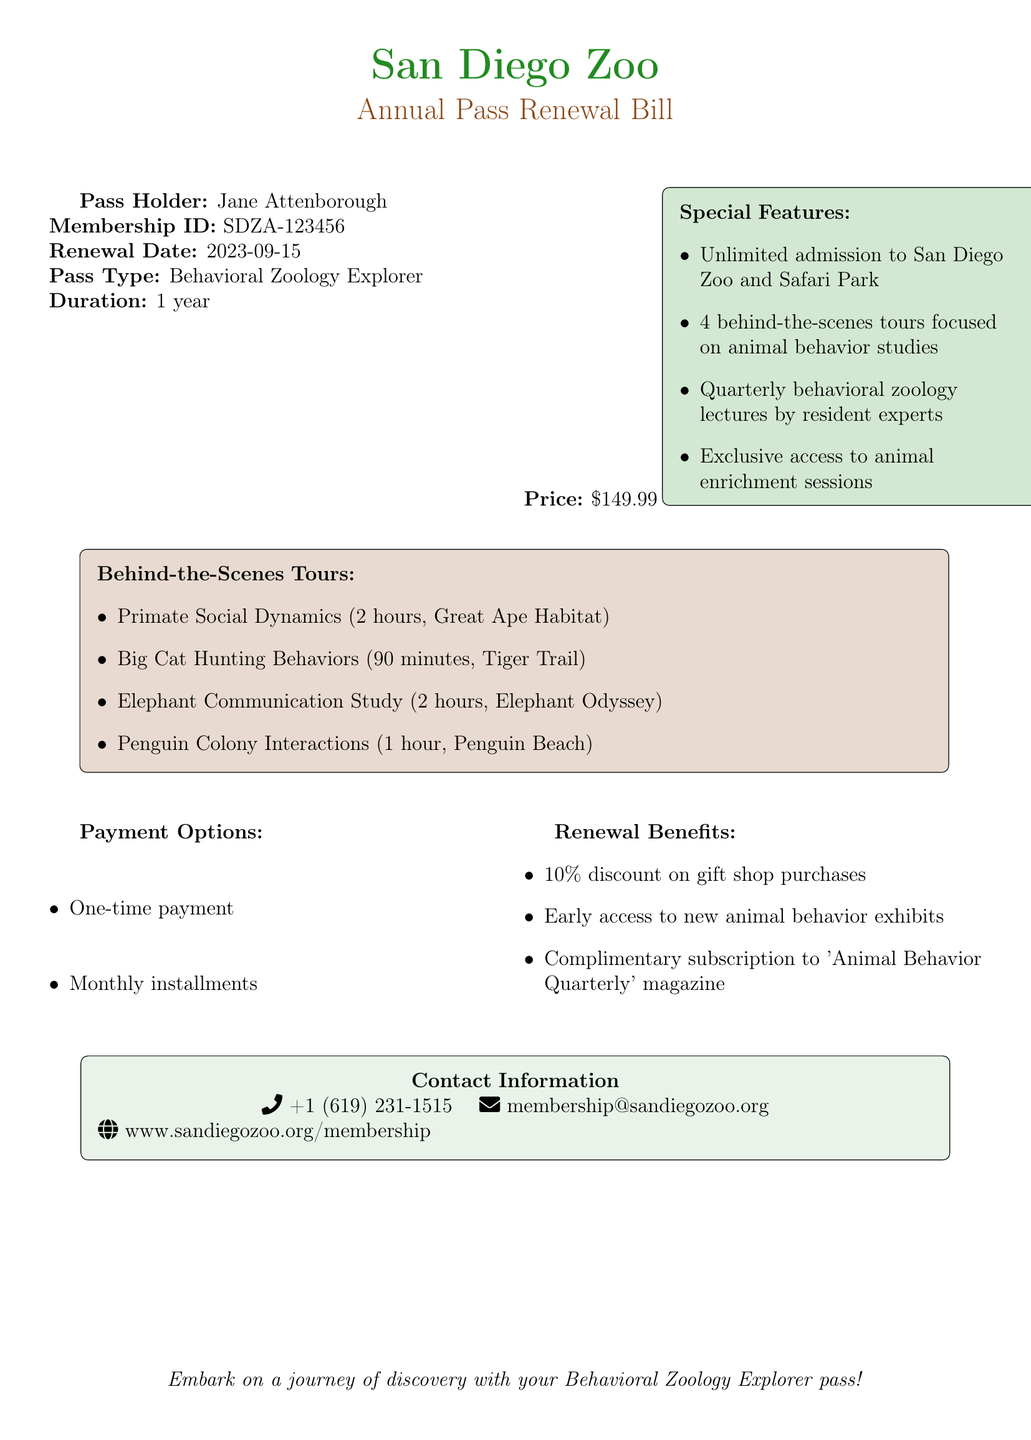What is the name of the pass holder? The name of the pass holder is listed as Jane Attenborough in the document.
Answer: Jane Attenborough What is the membership ID? The membership ID is provided in the document as SDZA-123456.
Answer: SDZA-123456 What is the price of the pass? The document specifies that the price of the pass is $149.99.
Answer: $149.99 How many behind-the-scenes tours are included? The document states that there are 4 behind-the-scenes tours included.
Answer: 4 What is one of the special features of the pass? The document lists several special features, one of which is unlimited admission to the San Diego Zoo and Safari Park.
Answer: Unlimited admission to San Diego Zoo and Safari Park What type of communication study is featured in the tours? The document mentions the Elephant Communication Study among the behind-the-scenes tours.
Answer: Elephant Communication Study What is one of the payment options available? The document describes two payment options, including one-time payment.
Answer: One-time payment What is the duration of the pass? The pass duration mentioned in the document is 1 year.
Answer: 1 year What is the name of the magazine subscribers will receive? The document states that subscribers will receive 'Animal Behavior Quarterly' magazine.
Answer: 'Animal Behavior Quarterly' 